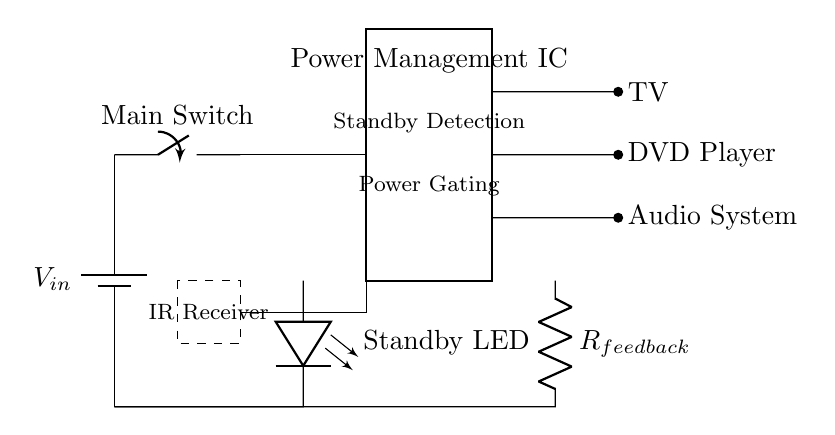What is the main purpose of the Power Management IC? The main purpose of the Power Management IC is to detect standby power consumption and manage power gating to reduce energy usage.
Answer: Standby power management What devices are connected to the outputs of the Power Management IC? The devices connected to the outputs are the TV, DVD Player, and Audio System, indicated by their respective output lines in the circuit.
Answer: TV, DVD Player, Audio System How is the standby indicator represented in the circuit? The standby indicator is represented by an LED labeled "Standby LED," which visually indicates when the circuit is in standby mode.
Answer: LED What type of feedback component is used in the circuit? The feedback component used in the circuit is a resistor labeled "R_feedback," which is crucial for the operation of the circuit and maintaining correct functionality.
Answer: Resistor What does the dashed rectangle represent, and what is its function? The dashed rectangle represents the IR Receiver, which functions to receive signals from remote controls to toggle the power management features.
Answer: IR Receiver How does the circuit determine when to engage or disengage devices from power? The circuit determines when to engage or disengage devices through standby detection by the Power Management IC, which activates power gating based on usage signals from the IR Receiver.
Answer: Standby detection and power gating Which component directly influences the feedback to the Power Management IC? The component that directly influences the feedback to the Power Management IC is the resistor labeled "R_feedback," which provides necessary feedback to optimize energy consumption.
Answer: R_feedback 